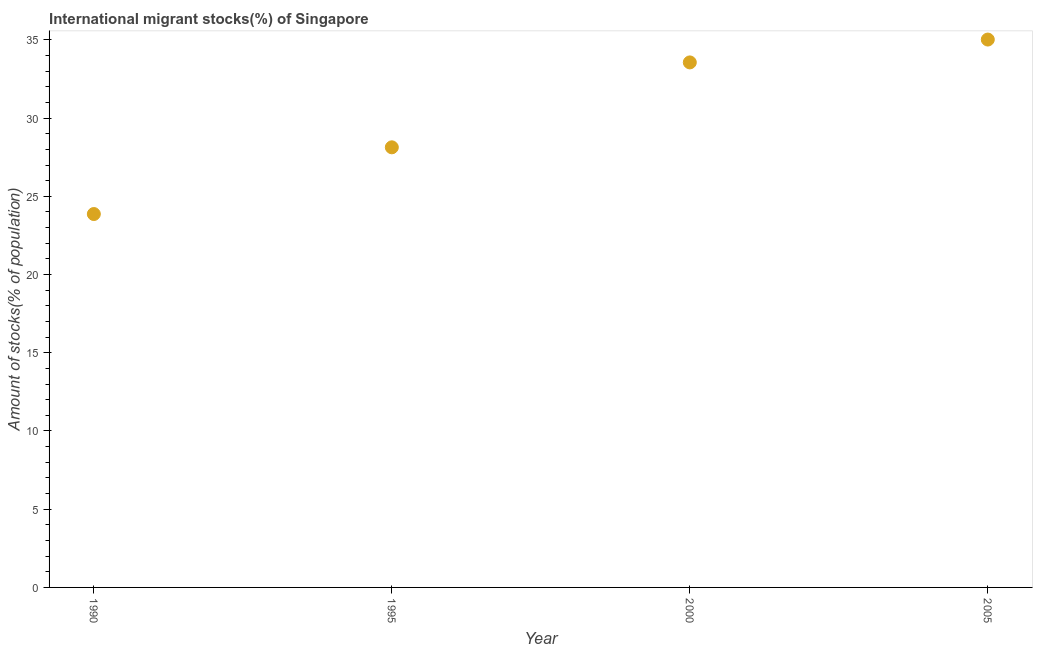What is the number of international migrant stocks in 2005?
Keep it short and to the point. 35.02. Across all years, what is the maximum number of international migrant stocks?
Make the answer very short. 35.02. Across all years, what is the minimum number of international migrant stocks?
Make the answer very short. 23.87. In which year was the number of international migrant stocks minimum?
Provide a short and direct response. 1990. What is the sum of the number of international migrant stocks?
Your response must be concise. 120.58. What is the difference between the number of international migrant stocks in 1995 and 2000?
Your response must be concise. -5.43. What is the average number of international migrant stocks per year?
Provide a short and direct response. 30.15. What is the median number of international migrant stocks?
Your response must be concise. 30.85. In how many years, is the number of international migrant stocks greater than 21 %?
Offer a terse response. 4. What is the ratio of the number of international migrant stocks in 1990 to that in 2005?
Offer a terse response. 0.68. Is the number of international migrant stocks in 2000 less than that in 2005?
Give a very brief answer. Yes. What is the difference between the highest and the second highest number of international migrant stocks?
Your answer should be very brief. 1.46. What is the difference between the highest and the lowest number of international migrant stocks?
Ensure brevity in your answer.  11.15. In how many years, is the number of international migrant stocks greater than the average number of international migrant stocks taken over all years?
Your response must be concise. 2. How many years are there in the graph?
Offer a terse response. 4. What is the difference between two consecutive major ticks on the Y-axis?
Ensure brevity in your answer.  5. Are the values on the major ticks of Y-axis written in scientific E-notation?
Offer a terse response. No. Does the graph contain any zero values?
Make the answer very short. No. Does the graph contain grids?
Keep it short and to the point. No. What is the title of the graph?
Provide a short and direct response. International migrant stocks(%) of Singapore. What is the label or title of the X-axis?
Your answer should be compact. Year. What is the label or title of the Y-axis?
Keep it short and to the point. Amount of stocks(% of population). What is the Amount of stocks(% of population) in 1990?
Offer a terse response. 23.87. What is the Amount of stocks(% of population) in 1995?
Provide a short and direct response. 28.13. What is the Amount of stocks(% of population) in 2000?
Make the answer very short. 33.56. What is the Amount of stocks(% of population) in 2005?
Your response must be concise. 35.02. What is the difference between the Amount of stocks(% of population) in 1990 and 1995?
Your answer should be very brief. -4.26. What is the difference between the Amount of stocks(% of population) in 1990 and 2000?
Provide a short and direct response. -9.69. What is the difference between the Amount of stocks(% of population) in 1990 and 2005?
Ensure brevity in your answer.  -11.15. What is the difference between the Amount of stocks(% of population) in 1995 and 2000?
Provide a succinct answer. -5.43. What is the difference between the Amount of stocks(% of population) in 1995 and 2005?
Ensure brevity in your answer.  -6.89. What is the difference between the Amount of stocks(% of population) in 2000 and 2005?
Offer a terse response. -1.46. What is the ratio of the Amount of stocks(% of population) in 1990 to that in 1995?
Give a very brief answer. 0.85. What is the ratio of the Amount of stocks(% of population) in 1990 to that in 2000?
Your answer should be very brief. 0.71. What is the ratio of the Amount of stocks(% of population) in 1990 to that in 2005?
Your response must be concise. 0.68. What is the ratio of the Amount of stocks(% of population) in 1995 to that in 2000?
Your answer should be compact. 0.84. What is the ratio of the Amount of stocks(% of population) in 1995 to that in 2005?
Offer a very short reply. 0.8. What is the ratio of the Amount of stocks(% of population) in 2000 to that in 2005?
Your response must be concise. 0.96. 